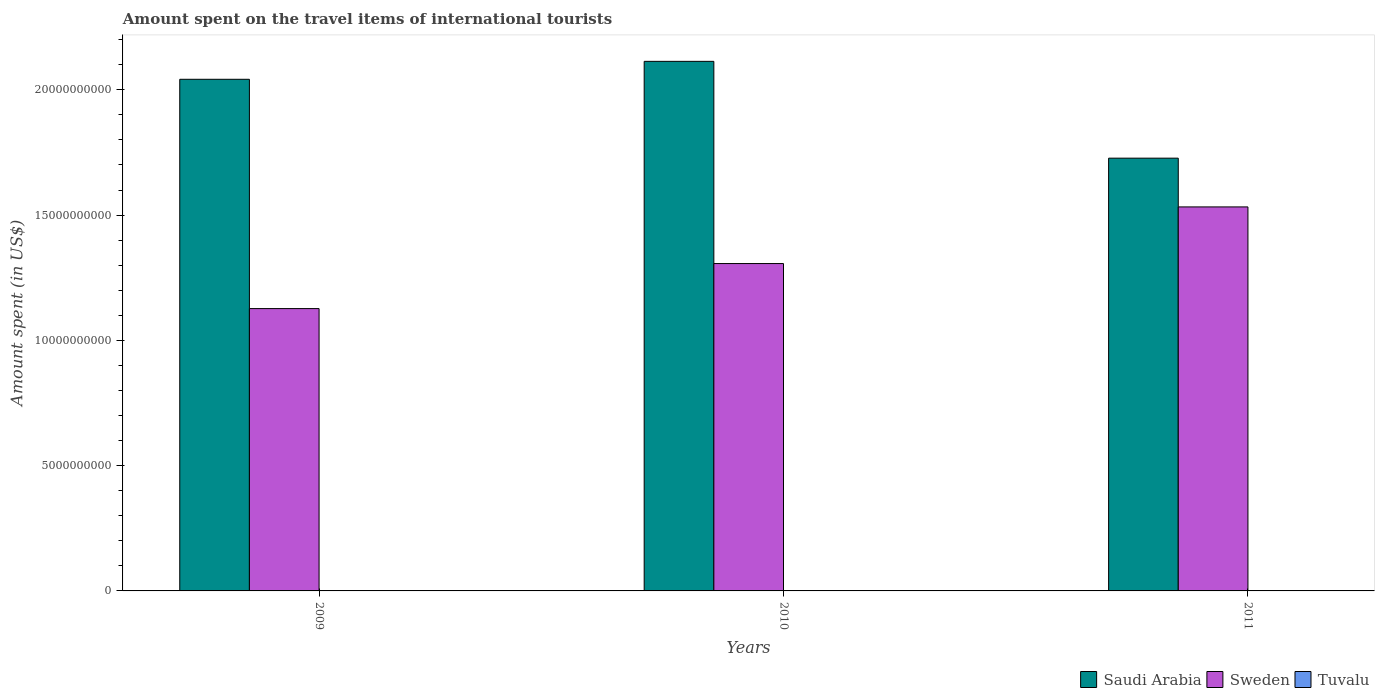How many groups of bars are there?
Give a very brief answer. 3. Are the number of bars per tick equal to the number of legend labels?
Give a very brief answer. Yes. How many bars are there on the 2nd tick from the left?
Your response must be concise. 3. In how many cases, is the number of bars for a given year not equal to the number of legend labels?
Make the answer very short. 0. What is the amount spent on the travel items of international tourists in Sweden in 2010?
Offer a very short reply. 1.31e+1. Across all years, what is the maximum amount spent on the travel items of international tourists in Tuvalu?
Keep it short and to the point. 9.65e+06. Across all years, what is the minimum amount spent on the travel items of international tourists in Tuvalu?
Give a very brief answer. 6.28e+06. In which year was the amount spent on the travel items of international tourists in Tuvalu minimum?
Your response must be concise. 2009. What is the total amount spent on the travel items of international tourists in Tuvalu in the graph?
Provide a succinct answer. 2.33e+07. What is the difference between the amount spent on the travel items of international tourists in Saudi Arabia in 2009 and that in 2011?
Keep it short and to the point. 3.15e+09. What is the difference between the amount spent on the travel items of international tourists in Sweden in 2010 and the amount spent on the travel items of international tourists in Tuvalu in 2009?
Your response must be concise. 1.31e+1. What is the average amount spent on the travel items of international tourists in Sweden per year?
Provide a succinct answer. 1.32e+1. In the year 2010, what is the difference between the amount spent on the travel items of international tourists in Tuvalu and amount spent on the travel items of international tourists in Saudi Arabia?
Provide a short and direct response. -2.11e+1. In how many years, is the amount spent on the travel items of international tourists in Sweden greater than 19000000000 US$?
Provide a succinct answer. 0. What is the ratio of the amount spent on the travel items of international tourists in Saudi Arabia in 2010 to that in 2011?
Your response must be concise. 1.22. Is the amount spent on the travel items of international tourists in Tuvalu in 2010 less than that in 2011?
Your answer should be compact. Yes. Is the difference between the amount spent on the travel items of international tourists in Tuvalu in 2009 and 2010 greater than the difference between the amount spent on the travel items of international tourists in Saudi Arabia in 2009 and 2010?
Offer a terse response. Yes. What is the difference between the highest and the second highest amount spent on the travel items of international tourists in Saudi Arabia?
Make the answer very short. 7.16e+08. What is the difference between the highest and the lowest amount spent on the travel items of international tourists in Saudi Arabia?
Offer a very short reply. 3.86e+09. What does the 1st bar from the left in 2011 represents?
Provide a short and direct response. Saudi Arabia. What does the 3rd bar from the right in 2010 represents?
Make the answer very short. Saudi Arabia. How many bars are there?
Your answer should be compact. 9. How many years are there in the graph?
Keep it short and to the point. 3. Are the values on the major ticks of Y-axis written in scientific E-notation?
Make the answer very short. No. Does the graph contain any zero values?
Provide a short and direct response. No. Does the graph contain grids?
Offer a terse response. No. Where does the legend appear in the graph?
Make the answer very short. Bottom right. How many legend labels are there?
Make the answer very short. 3. What is the title of the graph?
Keep it short and to the point. Amount spent on the travel items of international tourists. What is the label or title of the Y-axis?
Offer a very short reply. Amount spent (in US$). What is the Amount spent (in US$) of Saudi Arabia in 2009?
Give a very brief answer. 2.04e+1. What is the Amount spent (in US$) in Sweden in 2009?
Your answer should be compact. 1.13e+1. What is the Amount spent (in US$) of Tuvalu in 2009?
Your answer should be very brief. 6.28e+06. What is the Amount spent (in US$) of Saudi Arabia in 2010?
Offer a terse response. 2.11e+1. What is the Amount spent (in US$) of Sweden in 2010?
Provide a short and direct response. 1.31e+1. What is the Amount spent (in US$) in Tuvalu in 2010?
Provide a succinct answer. 7.41e+06. What is the Amount spent (in US$) of Saudi Arabia in 2011?
Provide a succinct answer. 1.73e+1. What is the Amount spent (in US$) of Sweden in 2011?
Your answer should be very brief. 1.53e+1. What is the Amount spent (in US$) in Tuvalu in 2011?
Your response must be concise. 9.65e+06. Across all years, what is the maximum Amount spent (in US$) in Saudi Arabia?
Give a very brief answer. 2.11e+1. Across all years, what is the maximum Amount spent (in US$) of Sweden?
Offer a terse response. 1.53e+1. Across all years, what is the maximum Amount spent (in US$) in Tuvalu?
Give a very brief answer. 9.65e+06. Across all years, what is the minimum Amount spent (in US$) of Saudi Arabia?
Provide a succinct answer. 1.73e+1. Across all years, what is the minimum Amount spent (in US$) of Sweden?
Offer a terse response. 1.13e+1. Across all years, what is the minimum Amount spent (in US$) in Tuvalu?
Offer a very short reply. 6.28e+06. What is the total Amount spent (in US$) in Saudi Arabia in the graph?
Make the answer very short. 5.88e+1. What is the total Amount spent (in US$) in Sweden in the graph?
Keep it short and to the point. 3.97e+1. What is the total Amount spent (in US$) in Tuvalu in the graph?
Offer a very short reply. 2.33e+07. What is the difference between the Amount spent (in US$) of Saudi Arabia in 2009 and that in 2010?
Ensure brevity in your answer.  -7.16e+08. What is the difference between the Amount spent (in US$) in Sweden in 2009 and that in 2010?
Provide a short and direct response. -1.80e+09. What is the difference between the Amount spent (in US$) of Tuvalu in 2009 and that in 2010?
Your answer should be very brief. -1.13e+06. What is the difference between the Amount spent (in US$) in Saudi Arabia in 2009 and that in 2011?
Ensure brevity in your answer.  3.15e+09. What is the difference between the Amount spent (in US$) in Sweden in 2009 and that in 2011?
Make the answer very short. -4.06e+09. What is the difference between the Amount spent (in US$) in Tuvalu in 2009 and that in 2011?
Ensure brevity in your answer.  -3.37e+06. What is the difference between the Amount spent (in US$) in Saudi Arabia in 2010 and that in 2011?
Your response must be concise. 3.86e+09. What is the difference between the Amount spent (in US$) of Sweden in 2010 and that in 2011?
Offer a terse response. -2.26e+09. What is the difference between the Amount spent (in US$) of Tuvalu in 2010 and that in 2011?
Ensure brevity in your answer.  -2.24e+06. What is the difference between the Amount spent (in US$) of Saudi Arabia in 2009 and the Amount spent (in US$) of Sweden in 2010?
Provide a short and direct response. 7.35e+09. What is the difference between the Amount spent (in US$) in Saudi Arabia in 2009 and the Amount spent (in US$) in Tuvalu in 2010?
Ensure brevity in your answer.  2.04e+1. What is the difference between the Amount spent (in US$) of Sweden in 2009 and the Amount spent (in US$) of Tuvalu in 2010?
Ensure brevity in your answer.  1.13e+1. What is the difference between the Amount spent (in US$) of Saudi Arabia in 2009 and the Amount spent (in US$) of Sweden in 2011?
Provide a short and direct response. 5.09e+09. What is the difference between the Amount spent (in US$) in Saudi Arabia in 2009 and the Amount spent (in US$) in Tuvalu in 2011?
Give a very brief answer. 2.04e+1. What is the difference between the Amount spent (in US$) of Sweden in 2009 and the Amount spent (in US$) of Tuvalu in 2011?
Provide a short and direct response. 1.13e+1. What is the difference between the Amount spent (in US$) in Saudi Arabia in 2010 and the Amount spent (in US$) in Sweden in 2011?
Provide a succinct answer. 5.81e+09. What is the difference between the Amount spent (in US$) of Saudi Arabia in 2010 and the Amount spent (in US$) of Tuvalu in 2011?
Give a very brief answer. 2.11e+1. What is the difference between the Amount spent (in US$) in Sweden in 2010 and the Amount spent (in US$) in Tuvalu in 2011?
Keep it short and to the point. 1.31e+1. What is the average Amount spent (in US$) in Saudi Arabia per year?
Keep it short and to the point. 1.96e+1. What is the average Amount spent (in US$) in Sweden per year?
Make the answer very short. 1.32e+1. What is the average Amount spent (in US$) in Tuvalu per year?
Ensure brevity in your answer.  7.78e+06. In the year 2009, what is the difference between the Amount spent (in US$) of Saudi Arabia and Amount spent (in US$) of Sweden?
Offer a terse response. 9.15e+09. In the year 2009, what is the difference between the Amount spent (in US$) in Saudi Arabia and Amount spent (in US$) in Tuvalu?
Make the answer very short. 2.04e+1. In the year 2009, what is the difference between the Amount spent (in US$) in Sweden and Amount spent (in US$) in Tuvalu?
Offer a very short reply. 1.13e+1. In the year 2010, what is the difference between the Amount spent (in US$) of Saudi Arabia and Amount spent (in US$) of Sweden?
Your answer should be compact. 8.07e+09. In the year 2010, what is the difference between the Amount spent (in US$) in Saudi Arabia and Amount spent (in US$) in Tuvalu?
Offer a terse response. 2.11e+1. In the year 2010, what is the difference between the Amount spent (in US$) in Sweden and Amount spent (in US$) in Tuvalu?
Give a very brief answer. 1.31e+1. In the year 2011, what is the difference between the Amount spent (in US$) of Saudi Arabia and Amount spent (in US$) of Sweden?
Ensure brevity in your answer.  1.94e+09. In the year 2011, what is the difference between the Amount spent (in US$) in Saudi Arabia and Amount spent (in US$) in Tuvalu?
Give a very brief answer. 1.73e+1. In the year 2011, what is the difference between the Amount spent (in US$) of Sweden and Amount spent (in US$) of Tuvalu?
Offer a terse response. 1.53e+1. What is the ratio of the Amount spent (in US$) of Saudi Arabia in 2009 to that in 2010?
Give a very brief answer. 0.97. What is the ratio of the Amount spent (in US$) of Sweden in 2009 to that in 2010?
Your answer should be compact. 0.86. What is the ratio of the Amount spent (in US$) of Tuvalu in 2009 to that in 2010?
Provide a succinct answer. 0.85. What is the ratio of the Amount spent (in US$) in Saudi Arabia in 2009 to that in 2011?
Provide a short and direct response. 1.18. What is the ratio of the Amount spent (in US$) of Sweden in 2009 to that in 2011?
Give a very brief answer. 0.74. What is the ratio of the Amount spent (in US$) in Tuvalu in 2009 to that in 2011?
Your response must be concise. 0.65. What is the ratio of the Amount spent (in US$) of Saudi Arabia in 2010 to that in 2011?
Make the answer very short. 1.22. What is the ratio of the Amount spent (in US$) in Sweden in 2010 to that in 2011?
Provide a short and direct response. 0.85. What is the ratio of the Amount spent (in US$) in Tuvalu in 2010 to that in 2011?
Offer a very short reply. 0.77. What is the difference between the highest and the second highest Amount spent (in US$) in Saudi Arabia?
Offer a very short reply. 7.16e+08. What is the difference between the highest and the second highest Amount spent (in US$) in Sweden?
Your answer should be very brief. 2.26e+09. What is the difference between the highest and the second highest Amount spent (in US$) of Tuvalu?
Provide a succinct answer. 2.24e+06. What is the difference between the highest and the lowest Amount spent (in US$) of Saudi Arabia?
Keep it short and to the point. 3.86e+09. What is the difference between the highest and the lowest Amount spent (in US$) in Sweden?
Give a very brief answer. 4.06e+09. What is the difference between the highest and the lowest Amount spent (in US$) in Tuvalu?
Keep it short and to the point. 3.37e+06. 